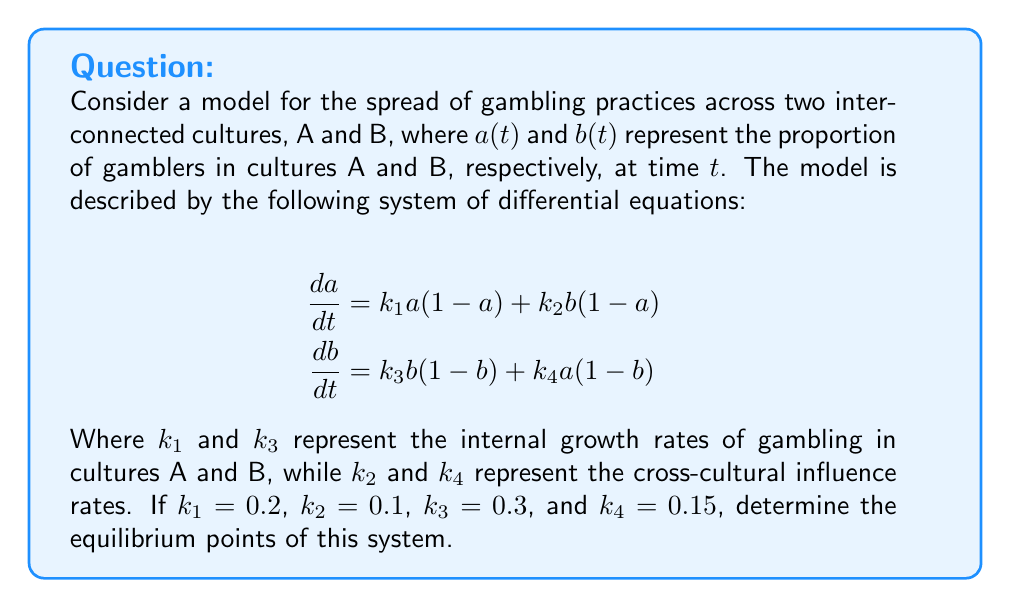Solve this math problem. To find the equilibrium points, we need to set both equations equal to zero and solve for $a$ and $b$:

1) Set $\frac{da}{dt} = 0$ and $\frac{db}{dt} = 0$:

   $$\begin{align}
   0 &= 0.2a(1-a) + 0.1b(1-a) \\
   0 &= 0.3b(1-b) + 0.15a(1-b)
   \end{align}$$

2) From the first equation:
   
   $0.2a - 0.2a^2 + 0.1b - 0.1ab = 0$
   $0.2a + 0.1b = 0.2a^2 + 0.1ab$
   $0.2 + 0.1\frac{b}{a} = 0.2a + 0.1b$ ... (1)

3) From the second equation:
   
   $0.3b - 0.3b^2 + 0.15a - 0.15ab = 0$
   $0.3b + 0.15a = 0.3b^2 + 0.15ab$
   $0.3 + 0.15\frac{a}{b} = 0.3b + 0.15a$ ... (2)

4) The trivial equilibrium point is $(0,0)$, which represents no gambling in either culture.

5) For non-trivial equilibrium points, we can solve equations (1) and (2) simultaneously:

   From (1): $\frac{b}{a} = 2a - 2 + b$
   From (2): $\frac{a}{b} = 2b - 2 + a$

6) These equations suggest that at equilibrium, $a = b$. Substituting this into either original equation:

   $0 = 0.2a(1-a) + 0.1a(1-a)$
   $0 = 0.3a(1-a)$

7) Solving this:
   
   $0.3a(1-a) = 0$
   $a = 0$ or $a = 1$

Therefore, the equilibrium points are $(0,0)$ and $(1,1)$.
Answer: $(0,0)$ and $(1,1)$ 